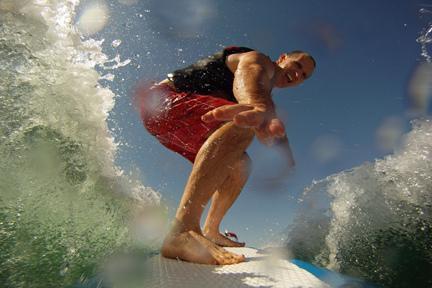How many people are in the picture?
Give a very brief answer. 1. How many women on bikes are in the picture?
Give a very brief answer. 0. 